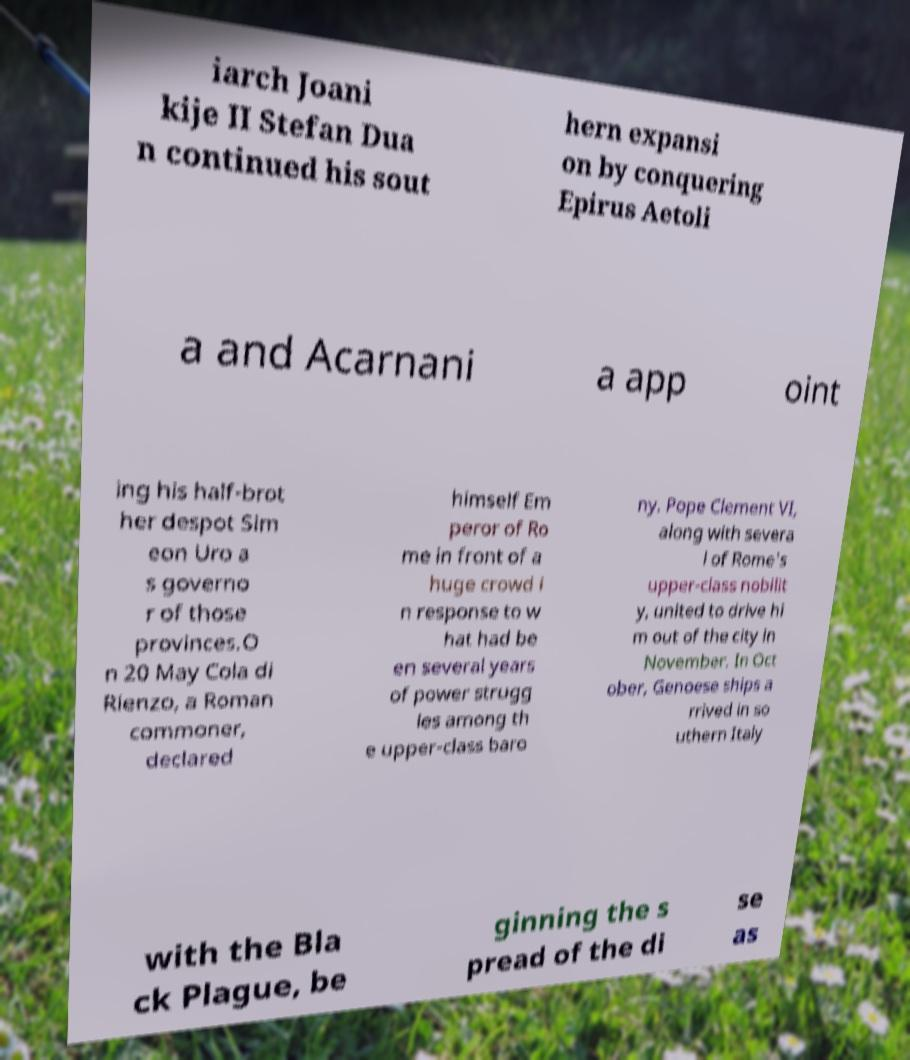Please read and relay the text visible in this image. What does it say? iarch Joani kije II Stefan Dua n continued his sout hern expansi on by conquering Epirus Aetoli a and Acarnani a app oint ing his half-brot her despot Sim eon Uro a s governo r of those provinces.O n 20 May Cola di Rienzo, a Roman commoner, declared himself Em peror of Ro me in front of a huge crowd i n response to w hat had be en several years of power strugg les among th e upper-class baro ny. Pope Clement VI, along with severa l of Rome's upper-class nobilit y, united to drive hi m out of the city in November. In Oct ober, Genoese ships a rrived in so uthern Italy with the Bla ck Plague, be ginning the s pread of the di se as 